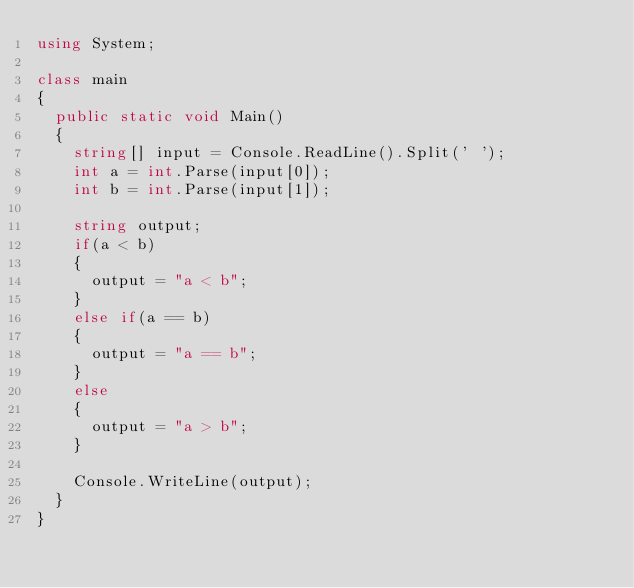<code> <loc_0><loc_0><loc_500><loc_500><_C#_>using System;

class main
{
	public static void Main()
	{
		string[] input = Console.ReadLine().Split(' ');
		int a = int.Parse(input[0]);
		int b = int.Parse(input[1]);

		string output;
		if(a < b)
		{
			output = "a < b";
		}
		else if(a == b)
		{
			output = "a == b";
		}
		else
		{
			output = "a > b";
		}

		Console.WriteLine(output);
	}
}</code> 